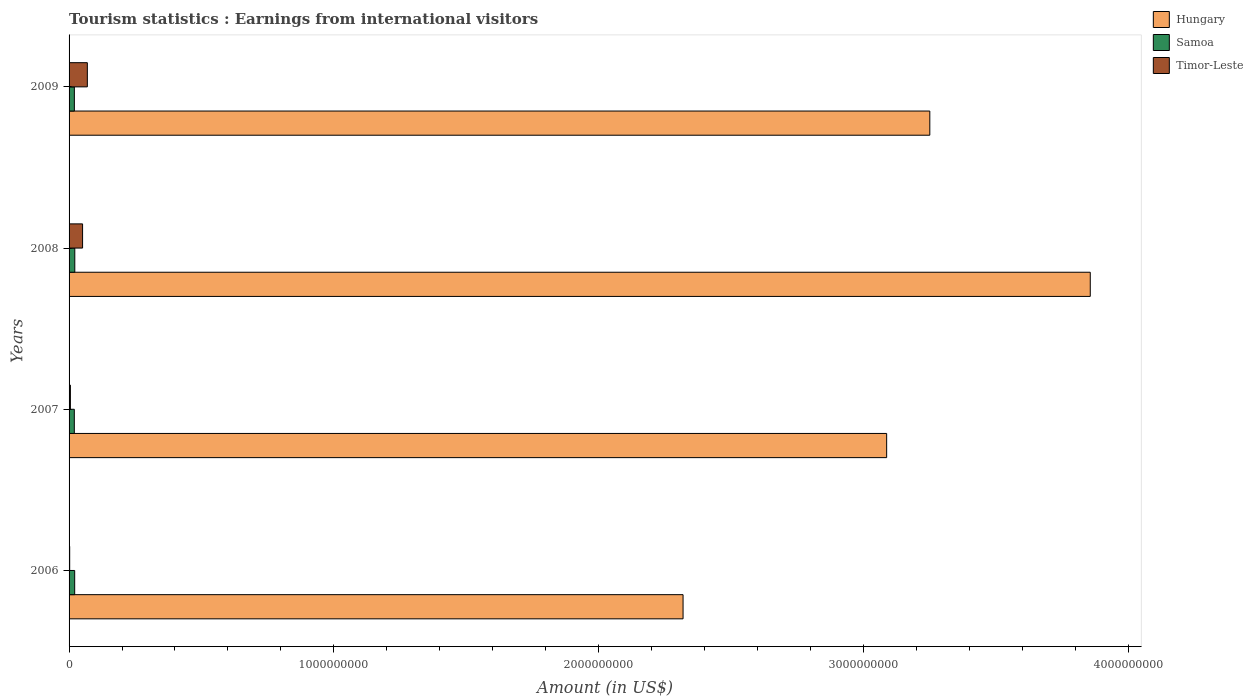How many groups of bars are there?
Offer a very short reply. 4. Are the number of bars on each tick of the Y-axis equal?
Ensure brevity in your answer.  Yes. What is the label of the 1st group of bars from the top?
Provide a succinct answer. 2009. What is the earnings from international visitors in Hungary in 2007?
Your answer should be very brief. 3.09e+09. Across all years, what is the maximum earnings from international visitors in Samoa?
Your answer should be compact. 2.16e+07. Across all years, what is the minimum earnings from international visitors in Samoa?
Offer a terse response. 1.98e+07. In which year was the earnings from international visitors in Samoa maximum?
Ensure brevity in your answer.  2008. In which year was the earnings from international visitors in Hungary minimum?
Offer a terse response. 2006. What is the total earnings from international visitors in Hungary in the graph?
Ensure brevity in your answer.  1.25e+1. What is the difference between the earnings from international visitors in Samoa in 2007 and that in 2009?
Your answer should be very brief. -2.00e+05. What is the difference between the earnings from international visitors in Hungary in 2006 and the earnings from international visitors in Timor-Leste in 2008?
Provide a succinct answer. 2.27e+09. What is the average earnings from international visitors in Hungary per year?
Provide a short and direct response. 3.13e+09. In the year 2007, what is the difference between the earnings from international visitors in Timor-Leste and earnings from international visitors in Hungary?
Ensure brevity in your answer.  -3.08e+09. In how many years, is the earnings from international visitors in Timor-Leste greater than 200000000 US$?
Your answer should be compact. 0. What is the difference between the highest and the second highest earnings from international visitors in Hungary?
Make the answer very short. 6.06e+08. What is the difference between the highest and the lowest earnings from international visitors in Timor-Leste?
Provide a succinct answer. 6.67e+07. In how many years, is the earnings from international visitors in Timor-Leste greater than the average earnings from international visitors in Timor-Leste taken over all years?
Offer a very short reply. 2. Is the sum of the earnings from international visitors in Samoa in 2006 and 2009 greater than the maximum earnings from international visitors in Timor-Leste across all years?
Provide a short and direct response. No. What does the 3rd bar from the top in 2009 represents?
Your answer should be very brief. Hungary. What does the 1st bar from the bottom in 2006 represents?
Your response must be concise. Hungary. Are all the bars in the graph horizontal?
Offer a very short reply. Yes. How many years are there in the graph?
Your response must be concise. 4. Are the values on the major ticks of X-axis written in scientific E-notation?
Offer a very short reply. No. Does the graph contain any zero values?
Your answer should be very brief. No. Does the graph contain grids?
Make the answer very short. No. Where does the legend appear in the graph?
Offer a very short reply. Top right. How many legend labels are there?
Keep it short and to the point. 3. What is the title of the graph?
Keep it short and to the point. Tourism statistics : Earnings from international visitors. What is the label or title of the X-axis?
Provide a short and direct response. Amount (in US$). What is the Amount (in US$) in Hungary in 2006?
Give a very brief answer. 2.32e+09. What is the Amount (in US$) in Samoa in 2006?
Give a very brief answer. 2.12e+07. What is the Amount (in US$) of Timor-Leste in 2006?
Keep it short and to the point. 2.30e+06. What is the Amount (in US$) in Hungary in 2007?
Provide a short and direct response. 3.09e+09. What is the Amount (in US$) in Samoa in 2007?
Your response must be concise. 1.98e+07. What is the Amount (in US$) of Hungary in 2008?
Make the answer very short. 3.86e+09. What is the Amount (in US$) of Samoa in 2008?
Provide a short and direct response. 2.16e+07. What is the Amount (in US$) in Timor-Leste in 2008?
Your answer should be very brief. 5.10e+07. What is the Amount (in US$) of Hungary in 2009?
Provide a succinct answer. 3.25e+09. What is the Amount (in US$) of Samoa in 2009?
Your answer should be compact. 2.00e+07. What is the Amount (in US$) in Timor-Leste in 2009?
Your answer should be very brief. 6.90e+07. Across all years, what is the maximum Amount (in US$) in Hungary?
Make the answer very short. 3.86e+09. Across all years, what is the maximum Amount (in US$) of Samoa?
Your response must be concise. 2.16e+07. Across all years, what is the maximum Amount (in US$) in Timor-Leste?
Offer a terse response. 6.90e+07. Across all years, what is the minimum Amount (in US$) of Hungary?
Offer a terse response. 2.32e+09. Across all years, what is the minimum Amount (in US$) of Samoa?
Keep it short and to the point. 1.98e+07. Across all years, what is the minimum Amount (in US$) in Timor-Leste?
Provide a succinct answer. 2.30e+06. What is the total Amount (in US$) of Hungary in the graph?
Provide a succinct answer. 1.25e+1. What is the total Amount (in US$) of Samoa in the graph?
Your answer should be compact. 8.26e+07. What is the total Amount (in US$) in Timor-Leste in the graph?
Your answer should be very brief. 1.27e+08. What is the difference between the Amount (in US$) in Hungary in 2006 and that in 2007?
Provide a succinct answer. -7.69e+08. What is the difference between the Amount (in US$) in Samoa in 2006 and that in 2007?
Offer a very short reply. 1.40e+06. What is the difference between the Amount (in US$) in Timor-Leste in 2006 and that in 2007?
Offer a very short reply. -2.70e+06. What is the difference between the Amount (in US$) of Hungary in 2006 and that in 2008?
Provide a succinct answer. -1.54e+09. What is the difference between the Amount (in US$) of Samoa in 2006 and that in 2008?
Your answer should be compact. -4.00e+05. What is the difference between the Amount (in US$) in Timor-Leste in 2006 and that in 2008?
Provide a succinct answer. -4.87e+07. What is the difference between the Amount (in US$) of Hungary in 2006 and that in 2009?
Provide a succinct answer. -9.32e+08. What is the difference between the Amount (in US$) in Samoa in 2006 and that in 2009?
Your answer should be very brief. 1.20e+06. What is the difference between the Amount (in US$) in Timor-Leste in 2006 and that in 2009?
Keep it short and to the point. -6.67e+07. What is the difference between the Amount (in US$) in Hungary in 2007 and that in 2008?
Give a very brief answer. -7.69e+08. What is the difference between the Amount (in US$) of Samoa in 2007 and that in 2008?
Provide a short and direct response. -1.80e+06. What is the difference between the Amount (in US$) of Timor-Leste in 2007 and that in 2008?
Your answer should be very brief. -4.60e+07. What is the difference between the Amount (in US$) in Hungary in 2007 and that in 2009?
Your answer should be compact. -1.63e+08. What is the difference between the Amount (in US$) of Samoa in 2007 and that in 2009?
Ensure brevity in your answer.  -2.00e+05. What is the difference between the Amount (in US$) in Timor-Leste in 2007 and that in 2009?
Offer a terse response. -6.40e+07. What is the difference between the Amount (in US$) of Hungary in 2008 and that in 2009?
Offer a terse response. 6.06e+08. What is the difference between the Amount (in US$) in Samoa in 2008 and that in 2009?
Ensure brevity in your answer.  1.60e+06. What is the difference between the Amount (in US$) in Timor-Leste in 2008 and that in 2009?
Provide a succinct answer. -1.80e+07. What is the difference between the Amount (in US$) in Hungary in 2006 and the Amount (in US$) in Samoa in 2007?
Provide a short and direct response. 2.30e+09. What is the difference between the Amount (in US$) in Hungary in 2006 and the Amount (in US$) in Timor-Leste in 2007?
Ensure brevity in your answer.  2.31e+09. What is the difference between the Amount (in US$) of Samoa in 2006 and the Amount (in US$) of Timor-Leste in 2007?
Ensure brevity in your answer.  1.62e+07. What is the difference between the Amount (in US$) of Hungary in 2006 and the Amount (in US$) of Samoa in 2008?
Provide a short and direct response. 2.30e+09. What is the difference between the Amount (in US$) in Hungary in 2006 and the Amount (in US$) in Timor-Leste in 2008?
Provide a short and direct response. 2.27e+09. What is the difference between the Amount (in US$) of Samoa in 2006 and the Amount (in US$) of Timor-Leste in 2008?
Ensure brevity in your answer.  -2.98e+07. What is the difference between the Amount (in US$) of Hungary in 2006 and the Amount (in US$) of Samoa in 2009?
Offer a terse response. 2.30e+09. What is the difference between the Amount (in US$) of Hungary in 2006 and the Amount (in US$) of Timor-Leste in 2009?
Offer a very short reply. 2.25e+09. What is the difference between the Amount (in US$) of Samoa in 2006 and the Amount (in US$) of Timor-Leste in 2009?
Keep it short and to the point. -4.78e+07. What is the difference between the Amount (in US$) in Hungary in 2007 and the Amount (in US$) in Samoa in 2008?
Offer a very short reply. 3.07e+09. What is the difference between the Amount (in US$) of Hungary in 2007 and the Amount (in US$) of Timor-Leste in 2008?
Your response must be concise. 3.04e+09. What is the difference between the Amount (in US$) in Samoa in 2007 and the Amount (in US$) in Timor-Leste in 2008?
Your answer should be compact. -3.12e+07. What is the difference between the Amount (in US$) of Hungary in 2007 and the Amount (in US$) of Samoa in 2009?
Keep it short and to the point. 3.07e+09. What is the difference between the Amount (in US$) of Hungary in 2007 and the Amount (in US$) of Timor-Leste in 2009?
Provide a short and direct response. 3.02e+09. What is the difference between the Amount (in US$) of Samoa in 2007 and the Amount (in US$) of Timor-Leste in 2009?
Provide a short and direct response. -4.92e+07. What is the difference between the Amount (in US$) in Hungary in 2008 and the Amount (in US$) in Samoa in 2009?
Give a very brief answer. 3.84e+09. What is the difference between the Amount (in US$) of Hungary in 2008 and the Amount (in US$) of Timor-Leste in 2009?
Give a very brief answer. 3.79e+09. What is the difference between the Amount (in US$) of Samoa in 2008 and the Amount (in US$) of Timor-Leste in 2009?
Make the answer very short. -4.74e+07. What is the average Amount (in US$) in Hungary per year?
Ensure brevity in your answer.  3.13e+09. What is the average Amount (in US$) of Samoa per year?
Your answer should be compact. 2.06e+07. What is the average Amount (in US$) of Timor-Leste per year?
Keep it short and to the point. 3.18e+07. In the year 2006, what is the difference between the Amount (in US$) of Hungary and Amount (in US$) of Samoa?
Offer a terse response. 2.30e+09. In the year 2006, what is the difference between the Amount (in US$) of Hungary and Amount (in US$) of Timor-Leste?
Ensure brevity in your answer.  2.32e+09. In the year 2006, what is the difference between the Amount (in US$) of Samoa and Amount (in US$) of Timor-Leste?
Give a very brief answer. 1.89e+07. In the year 2007, what is the difference between the Amount (in US$) in Hungary and Amount (in US$) in Samoa?
Give a very brief answer. 3.07e+09. In the year 2007, what is the difference between the Amount (in US$) in Hungary and Amount (in US$) in Timor-Leste?
Your response must be concise. 3.08e+09. In the year 2007, what is the difference between the Amount (in US$) of Samoa and Amount (in US$) of Timor-Leste?
Keep it short and to the point. 1.48e+07. In the year 2008, what is the difference between the Amount (in US$) in Hungary and Amount (in US$) in Samoa?
Offer a very short reply. 3.84e+09. In the year 2008, what is the difference between the Amount (in US$) in Hungary and Amount (in US$) in Timor-Leste?
Ensure brevity in your answer.  3.81e+09. In the year 2008, what is the difference between the Amount (in US$) of Samoa and Amount (in US$) of Timor-Leste?
Provide a succinct answer. -2.94e+07. In the year 2009, what is the difference between the Amount (in US$) in Hungary and Amount (in US$) in Samoa?
Provide a short and direct response. 3.23e+09. In the year 2009, what is the difference between the Amount (in US$) of Hungary and Amount (in US$) of Timor-Leste?
Your response must be concise. 3.18e+09. In the year 2009, what is the difference between the Amount (in US$) of Samoa and Amount (in US$) of Timor-Leste?
Your answer should be very brief. -4.90e+07. What is the ratio of the Amount (in US$) of Hungary in 2006 to that in 2007?
Provide a succinct answer. 0.75. What is the ratio of the Amount (in US$) in Samoa in 2006 to that in 2007?
Give a very brief answer. 1.07. What is the ratio of the Amount (in US$) of Timor-Leste in 2006 to that in 2007?
Offer a terse response. 0.46. What is the ratio of the Amount (in US$) of Hungary in 2006 to that in 2008?
Offer a very short reply. 0.6. What is the ratio of the Amount (in US$) in Samoa in 2006 to that in 2008?
Provide a succinct answer. 0.98. What is the ratio of the Amount (in US$) of Timor-Leste in 2006 to that in 2008?
Offer a very short reply. 0.05. What is the ratio of the Amount (in US$) of Hungary in 2006 to that in 2009?
Your answer should be very brief. 0.71. What is the ratio of the Amount (in US$) in Samoa in 2006 to that in 2009?
Your answer should be very brief. 1.06. What is the ratio of the Amount (in US$) of Timor-Leste in 2006 to that in 2009?
Your response must be concise. 0.03. What is the ratio of the Amount (in US$) in Hungary in 2007 to that in 2008?
Your answer should be very brief. 0.8. What is the ratio of the Amount (in US$) of Samoa in 2007 to that in 2008?
Offer a terse response. 0.92. What is the ratio of the Amount (in US$) in Timor-Leste in 2007 to that in 2008?
Provide a succinct answer. 0.1. What is the ratio of the Amount (in US$) of Hungary in 2007 to that in 2009?
Your response must be concise. 0.95. What is the ratio of the Amount (in US$) of Timor-Leste in 2007 to that in 2009?
Your answer should be compact. 0.07. What is the ratio of the Amount (in US$) of Hungary in 2008 to that in 2009?
Provide a short and direct response. 1.19. What is the ratio of the Amount (in US$) of Samoa in 2008 to that in 2009?
Keep it short and to the point. 1.08. What is the ratio of the Amount (in US$) in Timor-Leste in 2008 to that in 2009?
Your answer should be compact. 0.74. What is the difference between the highest and the second highest Amount (in US$) of Hungary?
Provide a succinct answer. 6.06e+08. What is the difference between the highest and the second highest Amount (in US$) in Samoa?
Your answer should be compact. 4.00e+05. What is the difference between the highest and the second highest Amount (in US$) of Timor-Leste?
Give a very brief answer. 1.80e+07. What is the difference between the highest and the lowest Amount (in US$) of Hungary?
Make the answer very short. 1.54e+09. What is the difference between the highest and the lowest Amount (in US$) of Samoa?
Keep it short and to the point. 1.80e+06. What is the difference between the highest and the lowest Amount (in US$) in Timor-Leste?
Make the answer very short. 6.67e+07. 